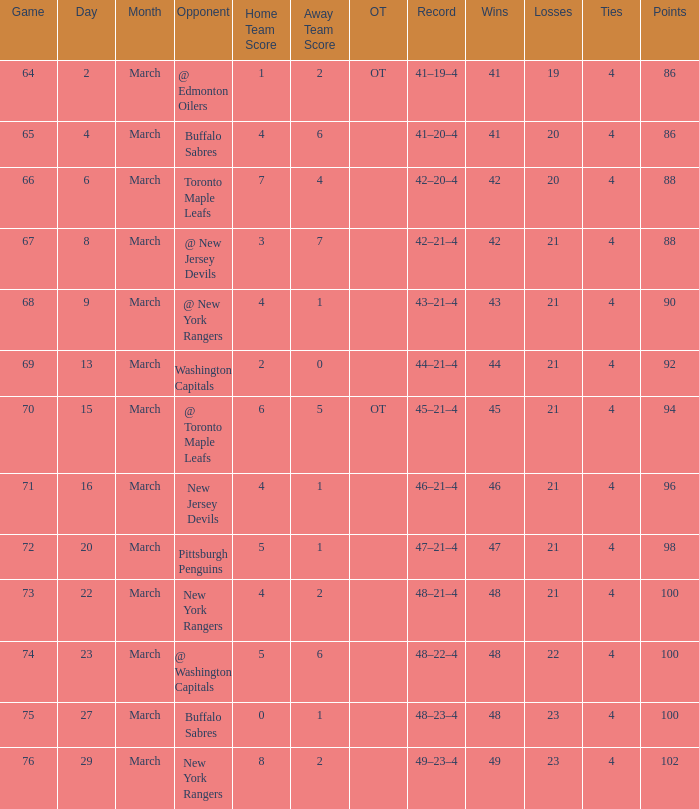Which score possesses a march bigger than 15, and points above 96, and a game lower than 76, and an opponent of @ washington capitals? 5–6. 